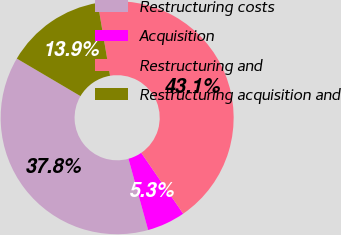<chart> <loc_0><loc_0><loc_500><loc_500><pie_chart><fcel>Restructuring costs<fcel>Acquisition<fcel>Restructuring and<fcel>Restructuring acquisition and<nl><fcel>37.76%<fcel>5.31%<fcel>43.07%<fcel>13.85%<nl></chart> 